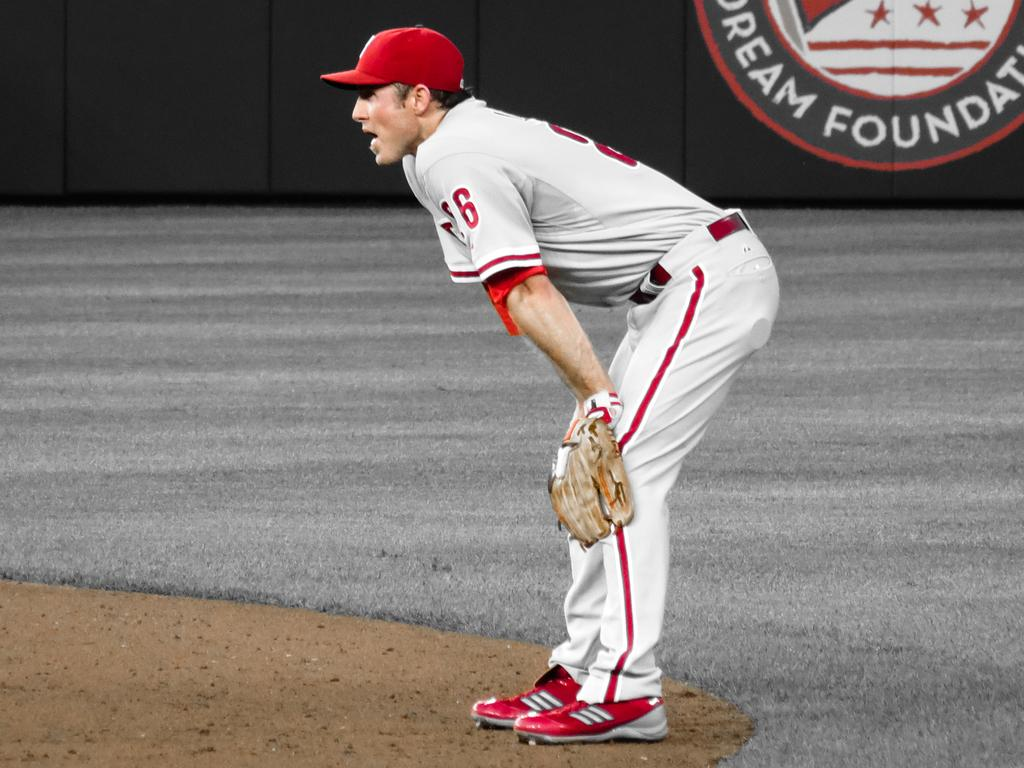<image>
Relay a brief, clear account of the picture shown. A baseball fielder is seen in front of a Dream Foundation sign on the outfield wall. 